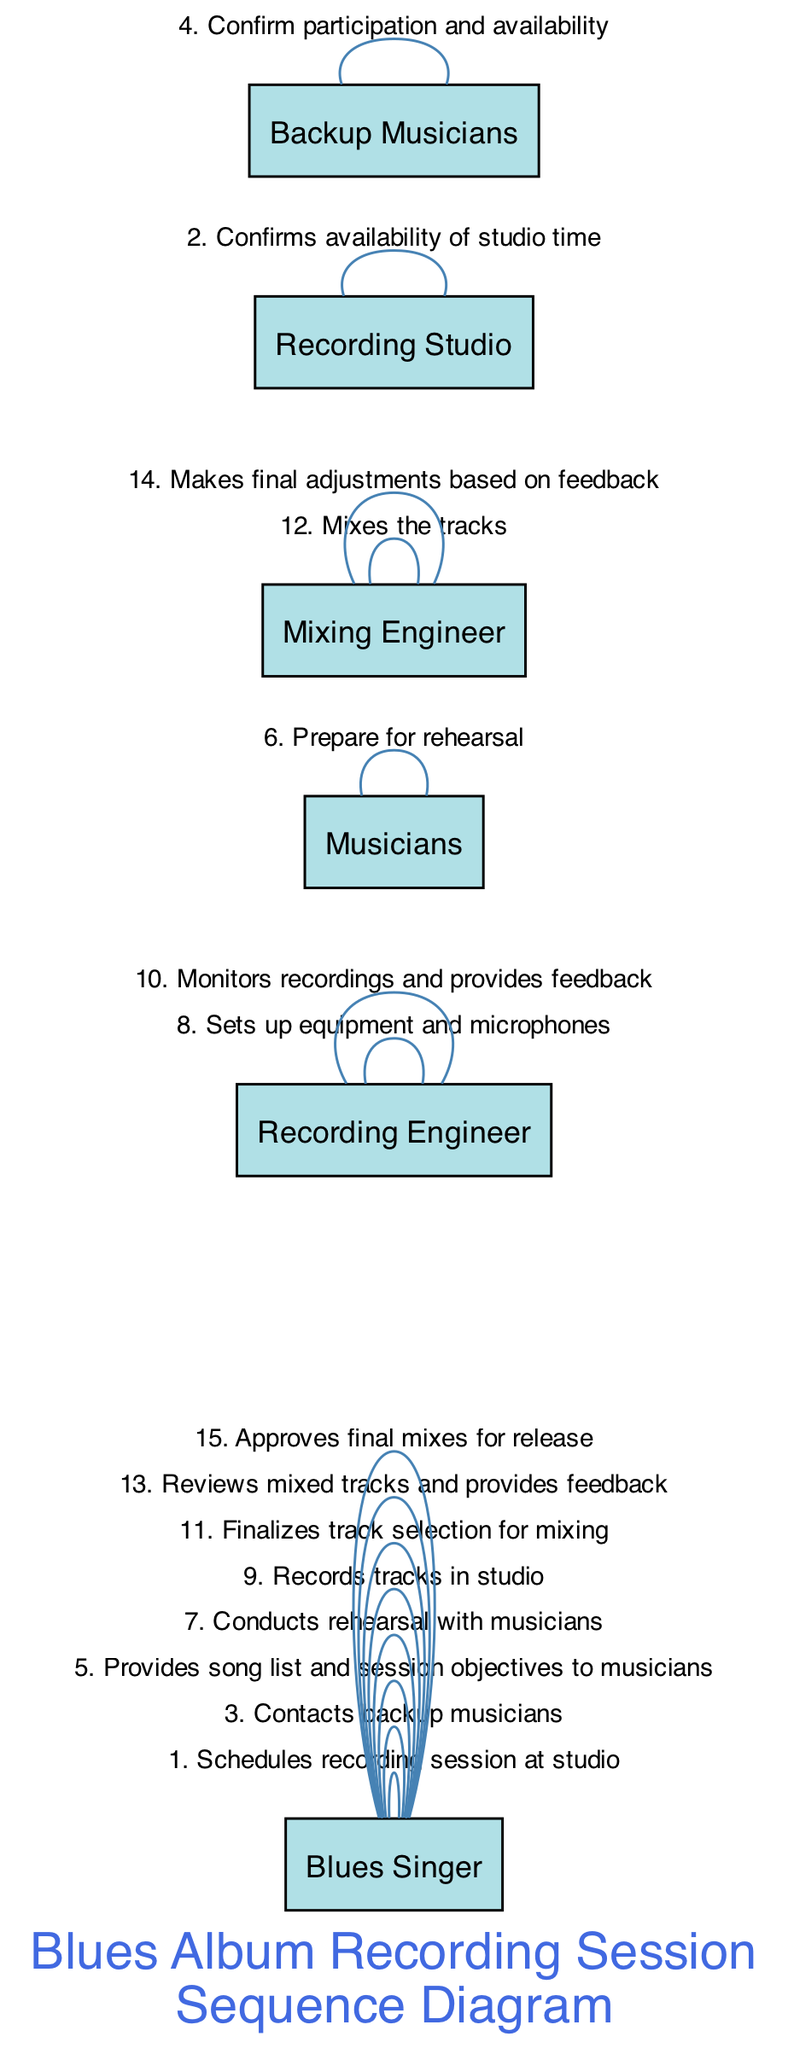What is the first action in the sequence? The first action in the sequence is performed by the Blues Singer, who schedules the recording session at the studio.
Answer: Schedules recording session at studio How many main actors are involved in this diagram? The main actors involved in this diagram are the Blues Singer, Recording Studio, Backup Musicians, Musicians, Recording Engineer, and Mixing Engineer, totaling six distinct actors.
Answer: Six Which actor confirms the availability of the studio time? It is the Recording Studio that confirms the availability of the studio time to the Blues Singer.
Answer: Recording Studio What action does the Blues Singer take after confirming with the backup musicians? After confirming with the backup musicians, the Blues Singer provides a song list and session objectives to the musicians, indicating what they should prepare for.
Answer: Provides song list and session objectives to musicians What happens after the Blues Singer conducts rehearsal with musicians? Following the rehearsal conducted by the Blues Singer, the Recording Engineer sets up equipment and microphones to prepare for the recording session.
Answer: Sets up equipment and microphones Which action directly follows the monitoring of recordings? After the Recording Engineer monitors the recordings and provides feedback, the Blues Singer finalizes the track selection for mixing, indicating the songs to be included.
Answer: Finalizes track selection for mixing Who makes final adjustments based on feedback from the Blues Singer? The Mixing Engineer is responsible for making the final adjustments based on the feedback provided by the Blues Singer regarding the mixed tracks.
Answer: Mixing Engineer What is the last action performed in the sequence? The last action performed in the sequence is when the Blues Singer approves the final mixes for release, indicating that the recording session is complete.
Answer: Approves final mixes for release How many actions does the Blues Singer perform in this sequence? The Blues Singer performs a total of five distinct actions throughout the sequence, which includes scheduling, contacting musicians, providing song list, conducting rehearsal, and finalizing tracks for mixing, as well as reviewing and approving mixes.
Answer: Five 